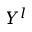Convert formula to latex. <formula><loc_0><loc_0><loc_500><loc_500>Y ^ { l }</formula> 